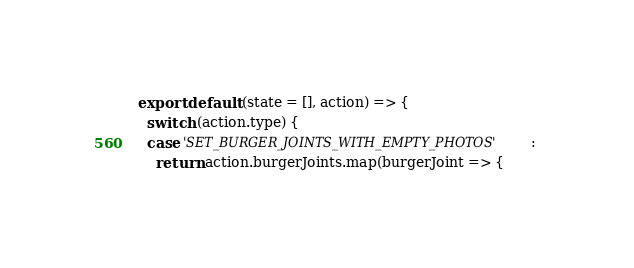Convert code to text. <code><loc_0><loc_0><loc_500><loc_500><_JavaScript_>export default (state = [], action) => {
  switch (action.type) {
  case 'SET_BURGER_JOINTS_WITH_EMPTY_PHOTOS': 
    return action.burgerJoints.map(burgerJoint => {</code> 